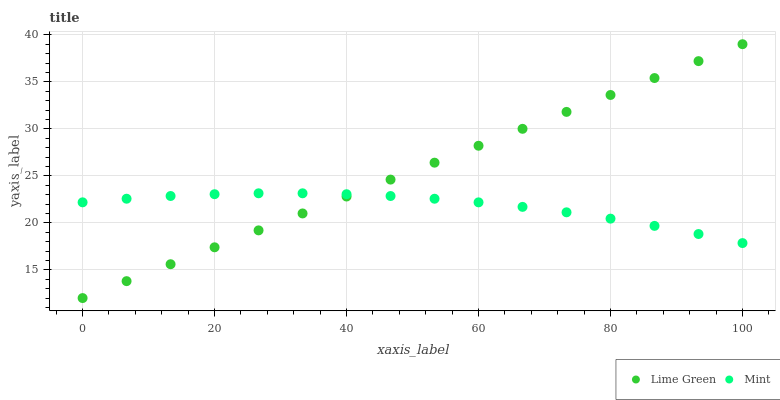Does Mint have the minimum area under the curve?
Answer yes or no. Yes. Does Lime Green have the maximum area under the curve?
Answer yes or no. Yes. Does Lime Green have the minimum area under the curve?
Answer yes or no. No. Is Lime Green the smoothest?
Answer yes or no. Yes. Is Mint the roughest?
Answer yes or no. Yes. Is Lime Green the roughest?
Answer yes or no. No. Does Lime Green have the lowest value?
Answer yes or no. Yes. Does Lime Green have the highest value?
Answer yes or no. Yes. Does Mint intersect Lime Green?
Answer yes or no. Yes. Is Mint less than Lime Green?
Answer yes or no. No. Is Mint greater than Lime Green?
Answer yes or no. No. 